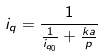Convert formula to latex. <formula><loc_0><loc_0><loc_500><loc_500>i _ { q } = \frac { 1 } { \frac { 1 } { i _ { q _ { 0 } } } + \frac { k a } { p } }</formula> 